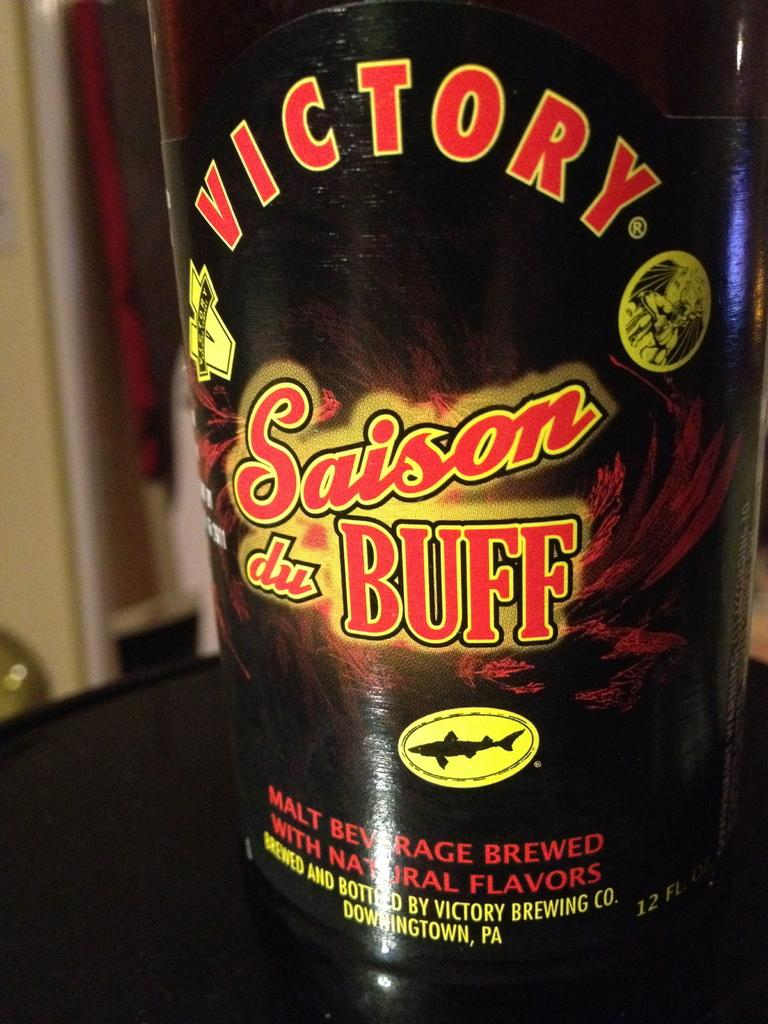<image>
Write a terse but informative summary of the picture. A close up of a bottle of Victory Saison du Buff malt beverage. 